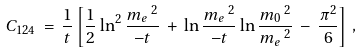<formula> <loc_0><loc_0><loc_500><loc_500>C _ { 1 2 4 } \, = \, \frac { 1 } { t } \left [ \frac { 1 } { 2 } \ln ^ { 2 } \frac { m _ { e } \, ^ { 2 } } { - t } \, + \, \ln \frac { m _ { e } \, ^ { 2 } } { - t } \ln \frac { m _ { 0 } \, ^ { 2 } } { m _ { e } \, ^ { 2 } } \, - \, \frac { \pi ^ { 2 } } { 6 } \right ] \, ,</formula> 